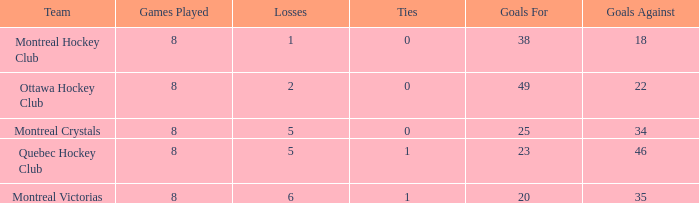What is the sum of the losses when the goals against is less than 34 and the games played is less than 8? None. 